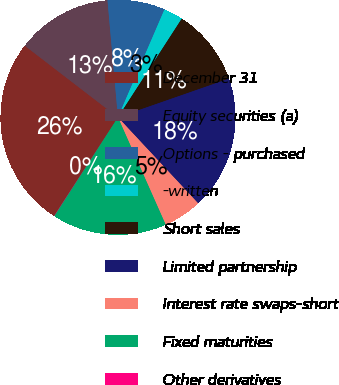Convert chart. <chart><loc_0><loc_0><loc_500><loc_500><pie_chart><fcel>December 31<fcel>Equity securities (a)<fcel>Options - purchased<fcel>-written<fcel>Short sales<fcel>Limited partnership<fcel>Interest rate swaps-short<fcel>Fixed maturities<fcel>Other derivatives<nl><fcel>26.28%<fcel>13.15%<fcel>7.9%<fcel>2.65%<fcel>10.53%<fcel>18.4%<fcel>5.28%<fcel>15.78%<fcel>0.03%<nl></chart> 